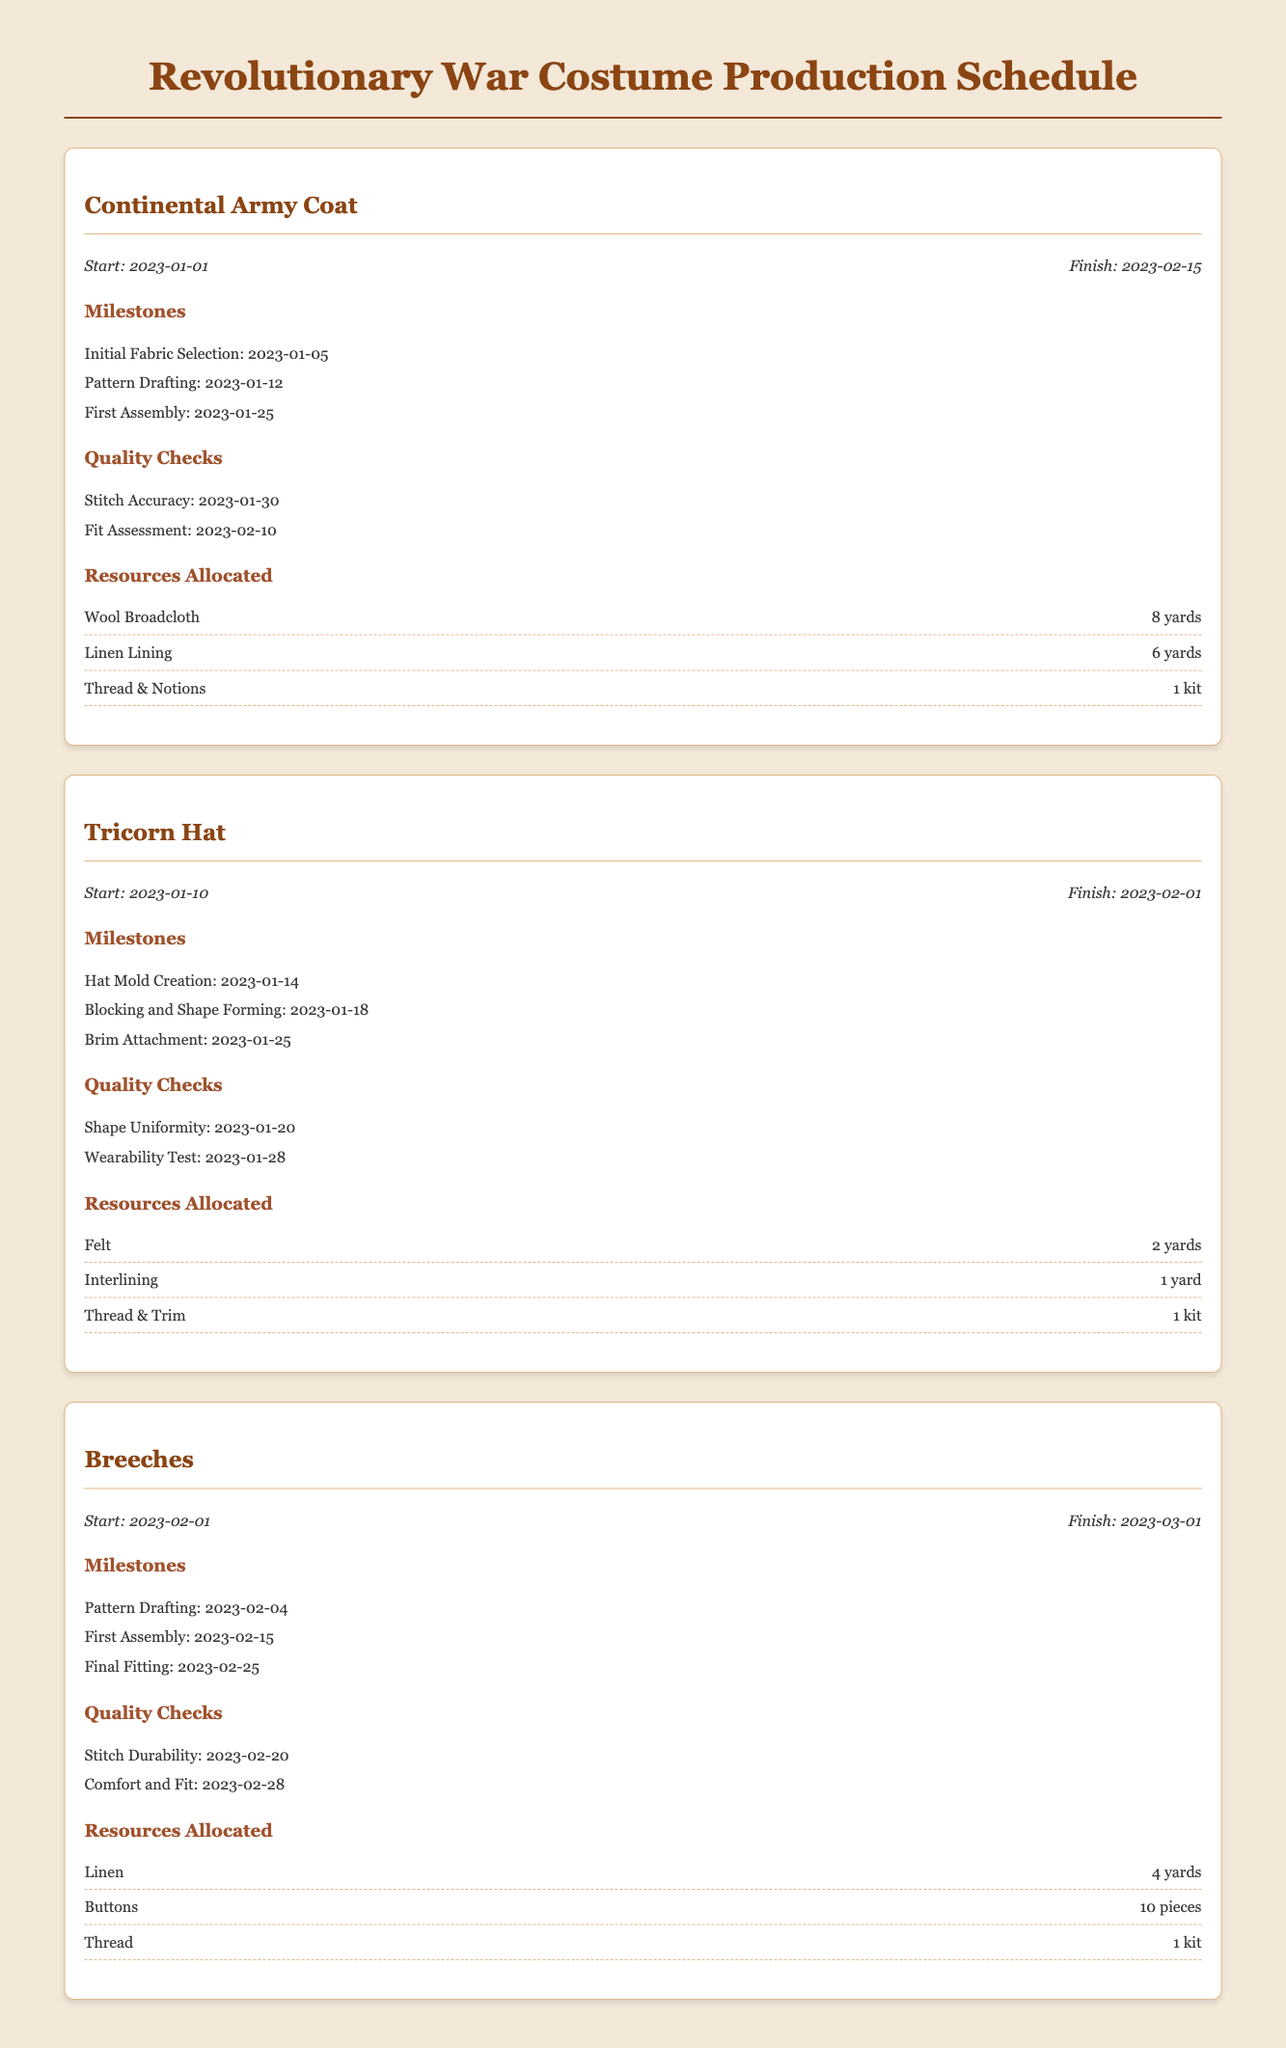What is the start date for the Continental Army Coat? The start date is explicitly mentioned in the document as 2023-01-01.
Answer: 2023-01-01 What resources are allocated for the Tricorn Hat? The resources allocated are listed in the document under "Resources Allocated" for the Tricorn Hat, which includes Felt, Interlining, and Thread & Trim.
Answer: Felt, Interlining, Thread & Trim When is the Final Fitting for the Breeches scheduled? The Final Fitting date is provided under the milestones for Breeches as 2023-02-25.
Answer: 2023-02-25 How many yards of Wool Broadcloth are allocated for the Continental Army Coat? The document specifies that 8 yards of Wool Broadcloth are allocated for the Continental Army Coat.
Answer: 8 yards What is the finish date for the Tricorn Hat? The finish date is noted in the document as 2023-02-01 for the Tricorn Hat.
Answer: 2023-02-01 What milestone is scheduled on 2023-01-18 for the Tricorn Hat? The milestone on that date refers to the "Blocking and Shape Forming", which is mentioned in the milestones section of the Tricorn Hat.
Answer: Blocking and Shape Forming Which quality check for the Breeches is focused on Stitch Durability? The quality check concerned with Stitch Durability is mentioned under the Quality Checks section for Breeches.
Answer: Stitch Durability What is the total number of quality checks listed for the Continental Army Coat? The document lists two quality checks for the Continental Army Coat: Stitch Accuracy and Fit Assessment.
Answer: 2 